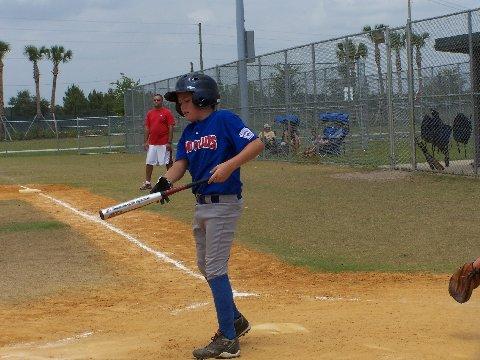What is the boy wearing on his head?
Quick response, please. Helmet. What color is the boy's uniform?
Short answer required. Blue. Is this a little league game?
Keep it brief. Yes. Is the man on the left wearing Nike?
Quick response, please. No. What is the bat made of?
Quick response, please. Aluminum. 